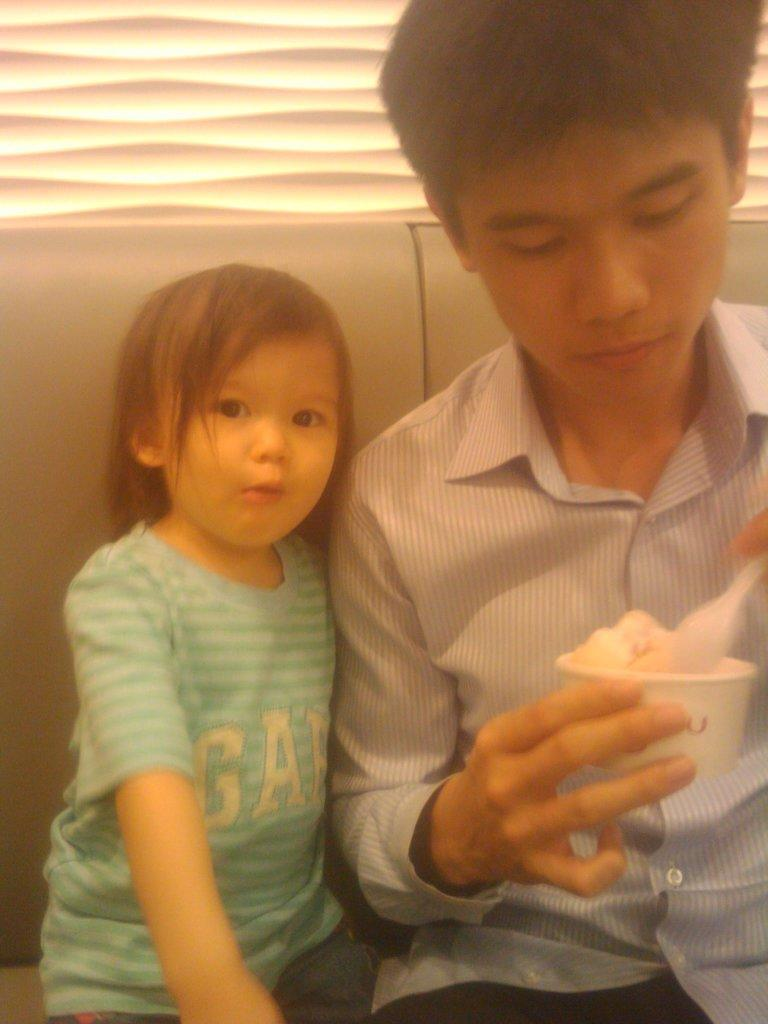How many people are sitting on the couch in the image? There are two people sitting on the couch in the image. What is one person holding in their hand? One person is holding a cup and a spoon. What is in the cup? There is food in the cup. What can be seen behind the person holding the cup? There is a wall behind the person. Where is the mailbox located in the image? There is no mailbox present in the image. What type of quilt is covering the couch in the image? There is no quilt visible in the image; the couch is not covered by any fabric. 